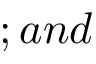<formula> <loc_0><loc_0><loc_500><loc_500>; a n d</formula> 